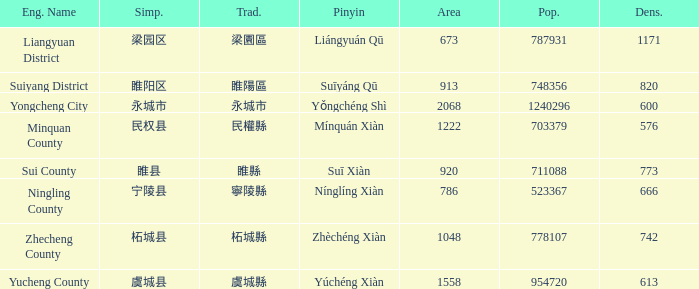What is the traditional with density of 820? 睢陽區. 